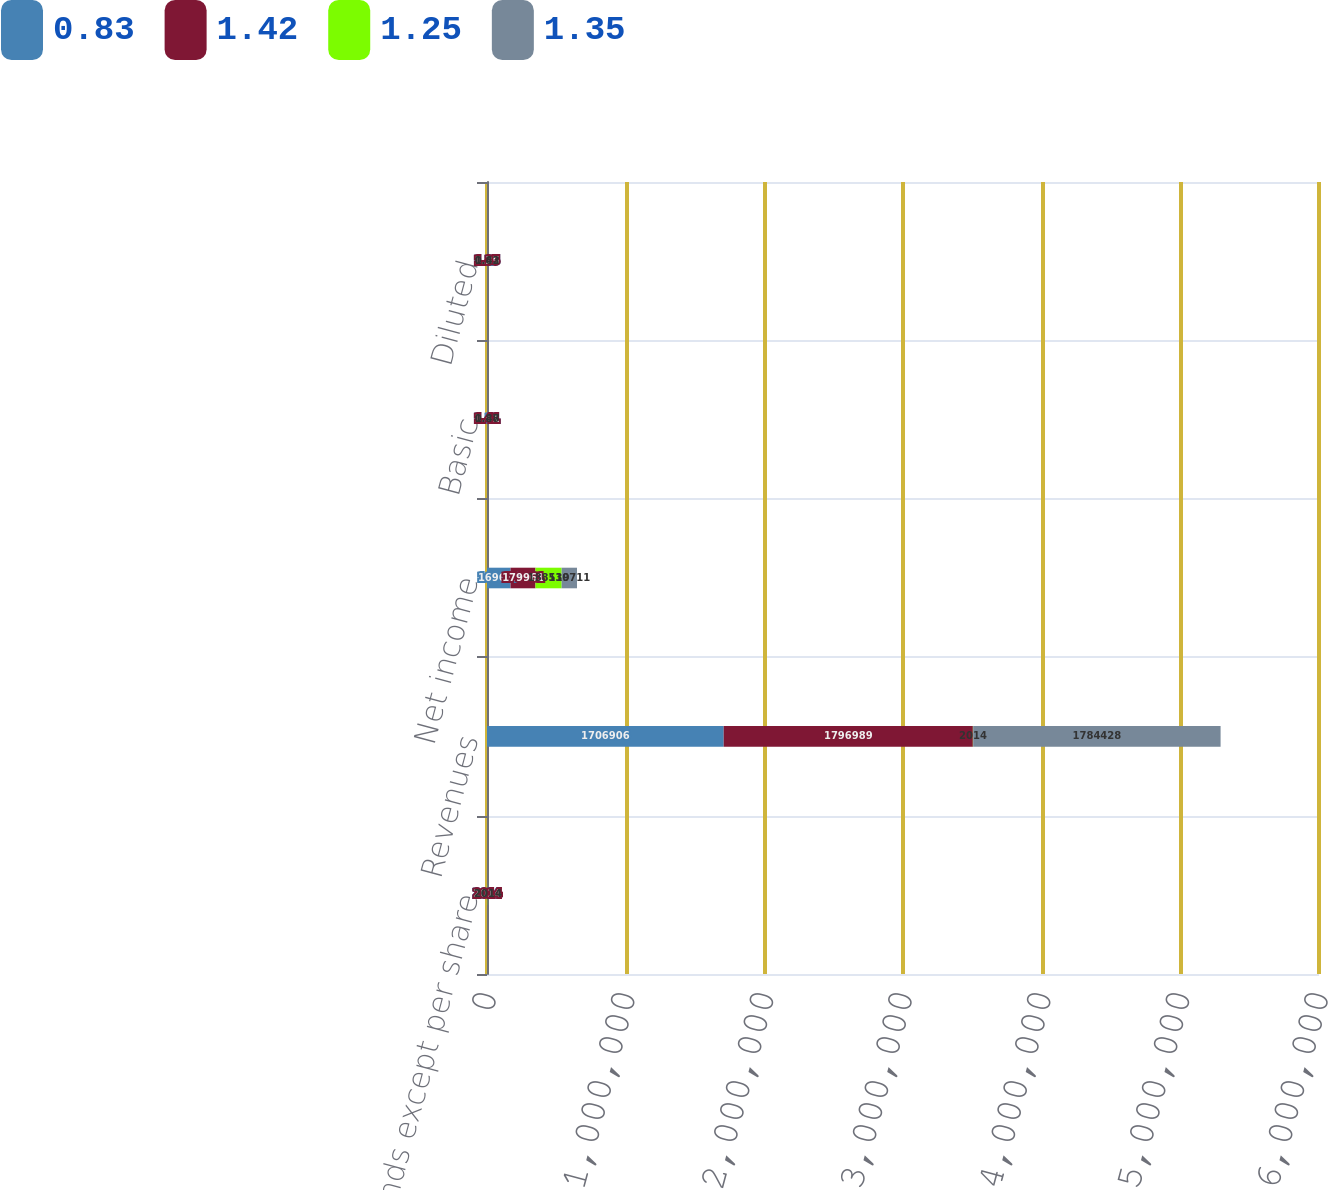<chart> <loc_0><loc_0><loc_500><loc_500><stacked_bar_chart><ecel><fcel>(In thousands except per share<fcel>Revenues<fcel>Net income<fcel>Basic<fcel>Diluted<nl><fcel>0.83<fcel>2014<fcel>1.70691e+06<fcel>169673<fcel>1.31<fcel>1.25<nl><fcel>1.42<fcel>2014<fcel>1.79699e+06<fcel>179961<fcel>1.41<fcel>1.35<nl><fcel>1.25<fcel>2014<fcel>2014<fcel>188539<fcel>1.48<fcel>1.42<nl><fcel>1.35<fcel>2014<fcel>1.78443e+06<fcel>110711<fcel>0.87<fcel>0.83<nl></chart> 